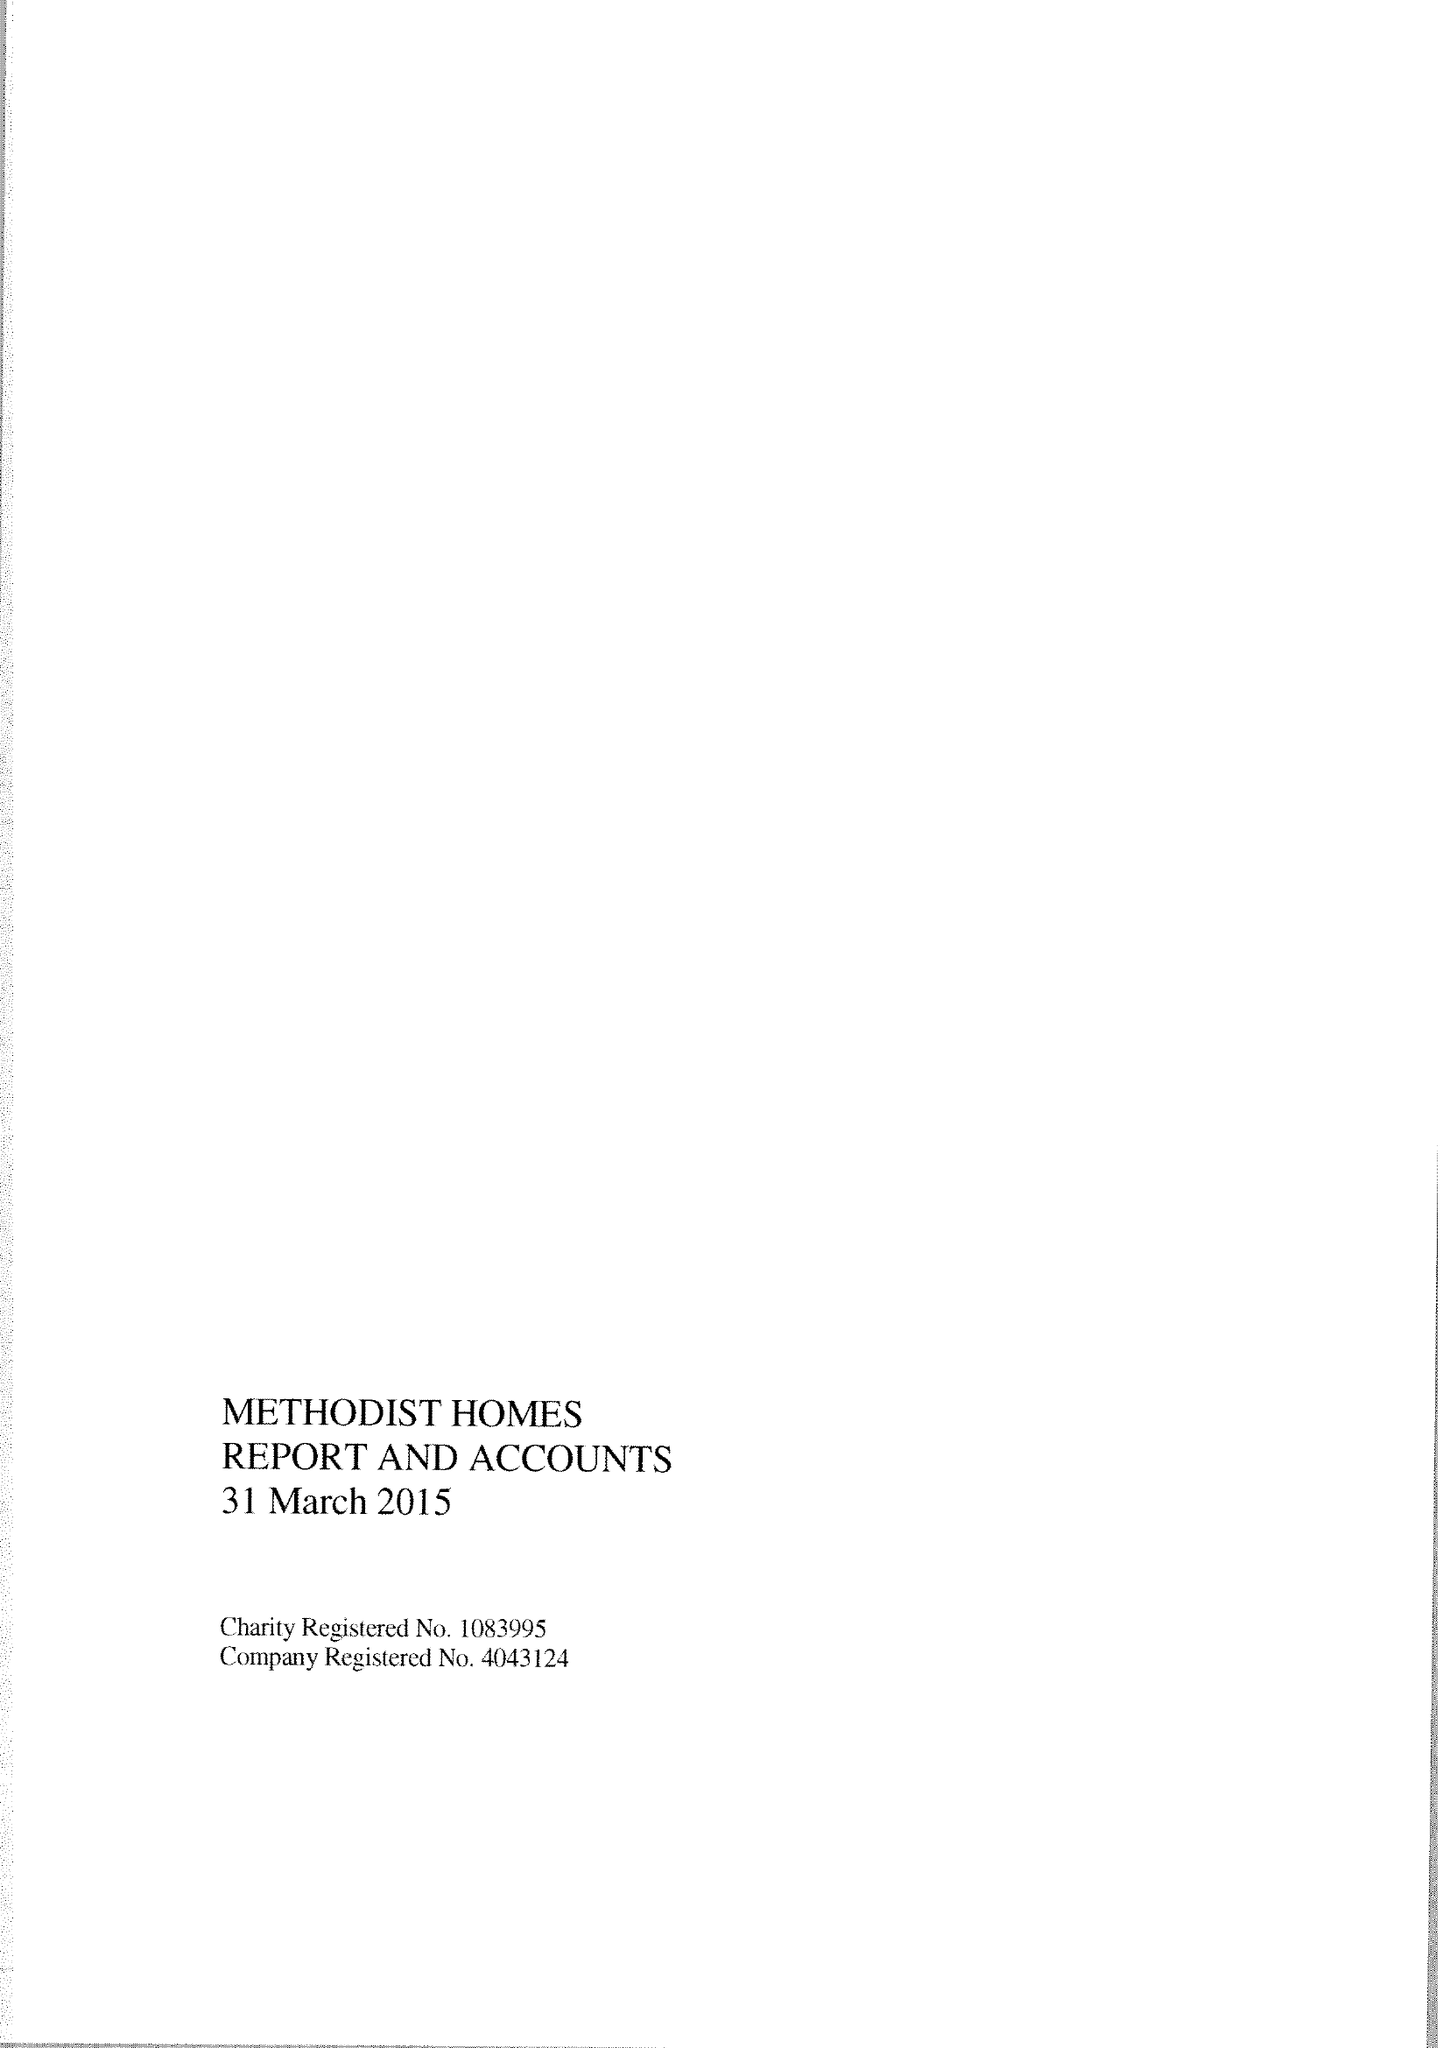What is the value for the charity_name?
Answer the question using a single word or phrase. Methodist Homes 